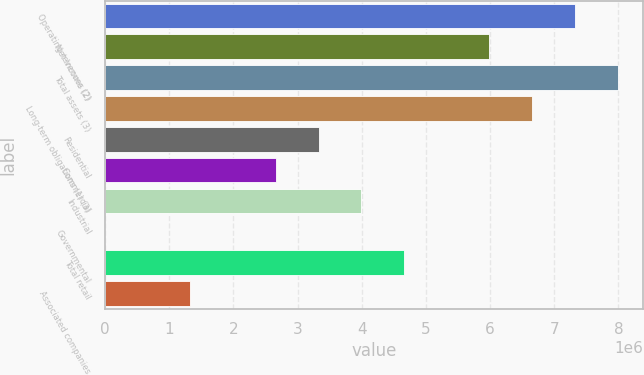Convert chart to OTSL. <chart><loc_0><loc_0><loc_500><loc_500><bar_chart><fcel>Operating revenues (2)<fcel>Net Income (2)<fcel>Total assets (3)<fcel>Long-term obligations (1) (3)<fcel>Residential<fcel>Commercial<fcel>Industrial<fcel>Governmental<fcel>Total retail<fcel>Associated companies<nl><fcel>7.32094e+06<fcel>5.98987e+06<fcel>7.98648e+06<fcel>6.6554e+06<fcel>3.32772e+06<fcel>2.66218e+06<fcel>3.99326e+06<fcel>37<fcel>4.65879e+06<fcel>1.33111e+06<nl></chart> 